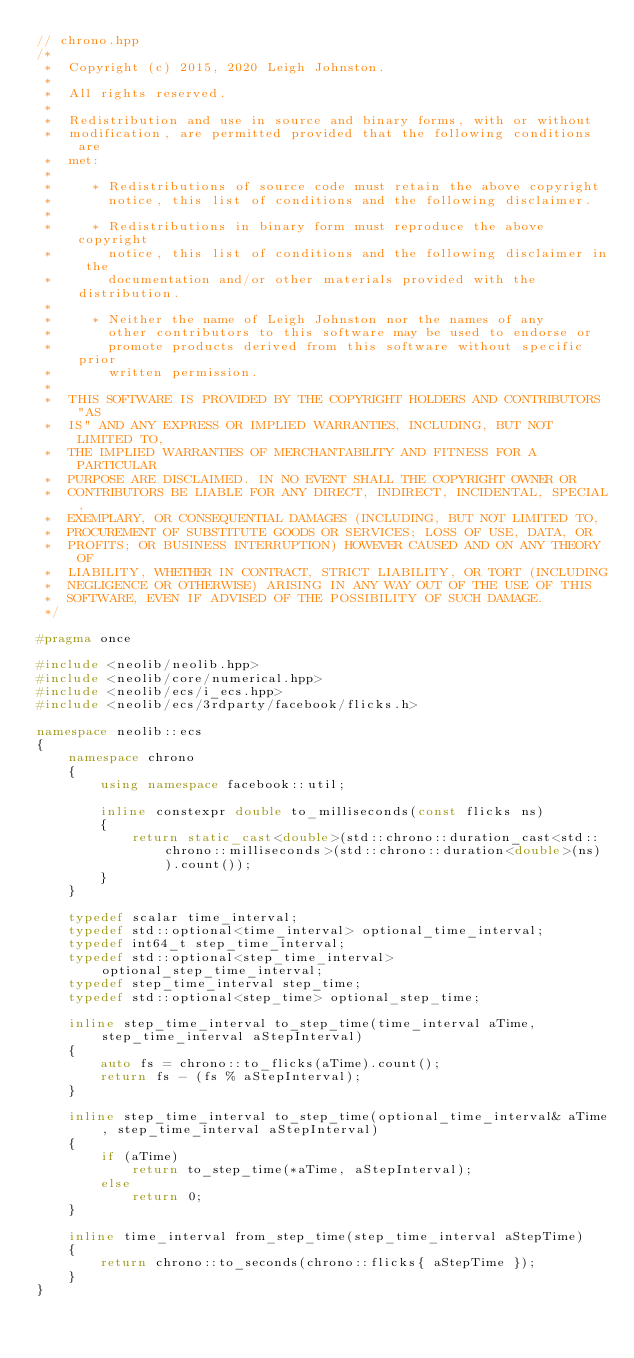<code> <loc_0><loc_0><loc_500><loc_500><_C++_>// chrono.hpp
/*
 *  Copyright (c) 2015, 2020 Leigh Johnston.
 *
 *  All rights reserved.
 *
 *  Redistribution and use in source and binary forms, with or without
 *  modification, are permitted provided that the following conditions are
 *  met:
 *
 *     * Redistributions of source code must retain the above copyright
 *       notice, this list of conditions and the following disclaimer.
 *
 *     * Redistributions in binary form must reproduce the above copyright
 *       notice, this list of conditions and the following disclaimer in the
 *       documentation and/or other materials provided with the distribution.
 *
 *     * Neither the name of Leigh Johnston nor the names of any
 *       other contributors to this software may be used to endorse or
 *       promote products derived from this software without specific prior
 *       written permission.
 *
 *  THIS SOFTWARE IS PROVIDED BY THE COPYRIGHT HOLDERS AND CONTRIBUTORS "AS
 *  IS" AND ANY EXPRESS OR IMPLIED WARRANTIES, INCLUDING, BUT NOT LIMITED TO,
 *  THE IMPLIED WARRANTIES OF MERCHANTABILITY AND FITNESS FOR A PARTICULAR
 *  PURPOSE ARE DISCLAIMED. IN NO EVENT SHALL THE COPYRIGHT OWNER OR
 *  CONTRIBUTORS BE LIABLE FOR ANY DIRECT, INDIRECT, INCIDENTAL, SPECIAL,
 *  EXEMPLARY, OR CONSEQUENTIAL DAMAGES (INCLUDING, BUT NOT LIMITED TO,
 *  PROCUREMENT OF SUBSTITUTE GOODS OR SERVICES; LOSS OF USE, DATA, OR
 *  PROFITS; OR BUSINESS INTERRUPTION) HOWEVER CAUSED AND ON ANY THEORY OF
 *  LIABILITY, WHETHER IN CONTRACT, STRICT LIABILITY, OR TORT (INCLUDING
 *  NEGLIGENCE OR OTHERWISE) ARISING IN ANY WAY OUT OF THE USE OF THIS
 *  SOFTWARE, EVEN IF ADVISED OF THE POSSIBILITY OF SUCH DAMAGE.
 */

#pragma once

#include <neolib/neolib.hpp>
#include <neolib/core/numerical.hpp>
#include <neolib/ecs/i_ecs.hpp>
#include <neolib/ecs/3rdparty/facebook/flicks.h>

namespace neolib::ecs
{
    namespace chrono
    {
        using namespace facebook::util;

        inline constexpr double to_milliseconds(const flicks ns)
        {
            return static_cast<double>(std::chrono::duration_cast<std::chrono::milliseconds>(std::chrono::duration<double>(ns)).count());
        }
    }

    typedef scalar time_interval;
    typedef std::optional<time_interval> optional_time_interval;
    typedef int64_t step_time_interval;
    typedef std::optional<step_time_interval> optional_step_time_interval;
    typedef step_time_interval step_time;
    typedef std::optional<step_time> optional_step_time;

    inline step_time_interval to_step_time(time_interval aTime, step_time_interval aStepInterval)
    {
        auto fs = chrono::to_flicks(aTime).count();
        return fs - (fs % aStepInterval);
    }

    inline step_time_interval to_step_time(optional_time_interval& aTime, step_time_interval aStepInterval)
    {
        if (aTime)
            return to_step_time(*aTime, aStepInterval);
        else
            return 0;
    }

    inline time_interval from_step_time(step_time_interval aStepTime)
    {
        return chrono::to_seconds(chrono::flicks{ aStepTime });
    }
}</code> 